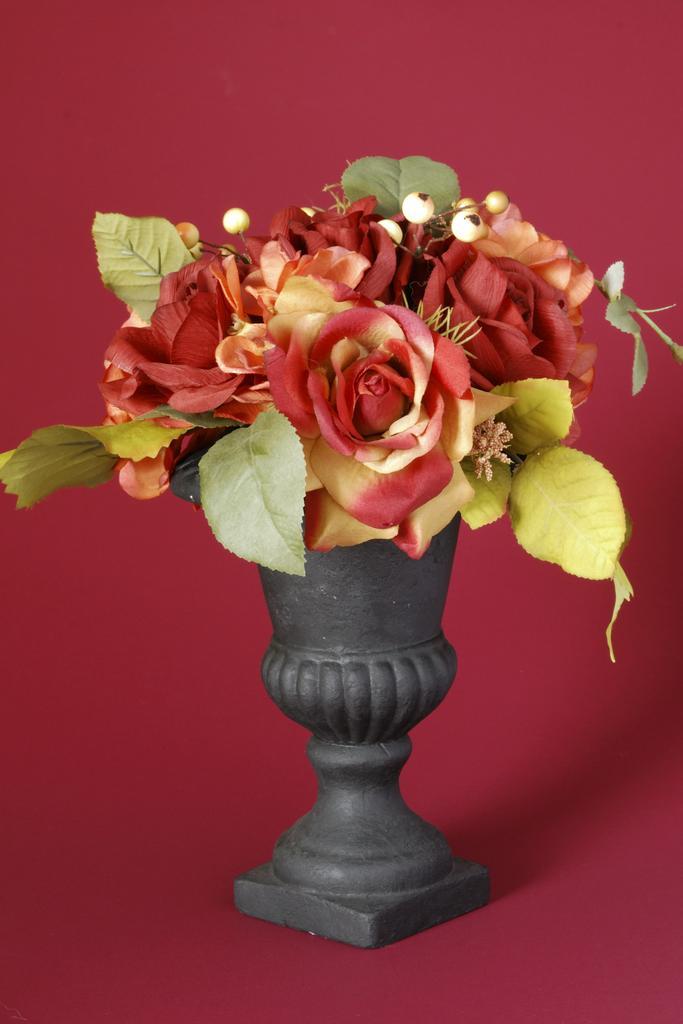Please provide a concise description of this image. In this image, we can see a flower pot with some flower and leaves. In the background, we can see the red color. 